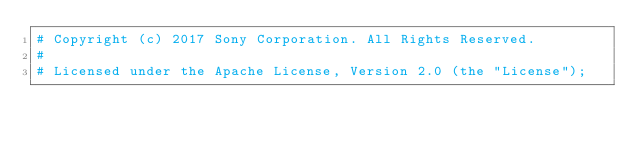<code> <loc_0><loc_0><loc_500><loc_500><_Cython_># Copyright (c) 2017 Sony Corporation. All Rights Reserved.
#
# Licensed under the Apache License, Version 2.0 (the "License");</code> 